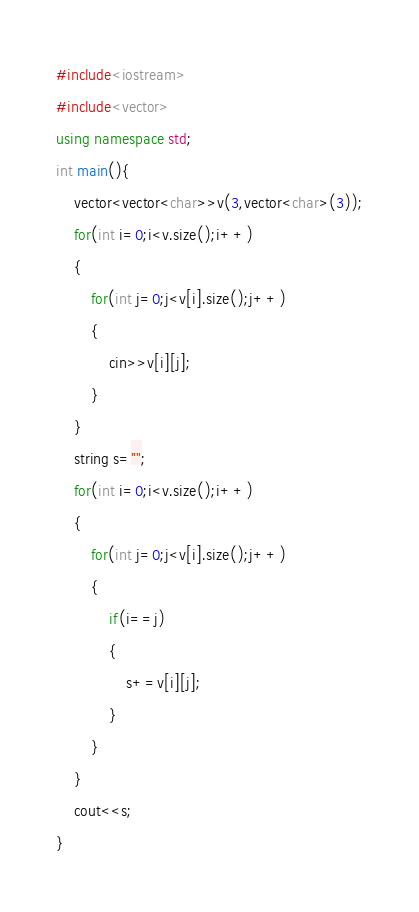<code> <loc_0><loc_0><loc_500><loc_500><_C++_>#include<iostream>
#include<vector>
using namespace std;
int main(){
    vector<vector<char>>v(3,vector<char>(3));
    for(int i=0;i<v.size();i++)
    {
        for(int j=0;j<v[i].size();j++)
        {
            cin>>v[i][j];
        }
    }
    string s="";
    for(int i=0;i<v.size();i++)
    {
        for(int j=0;j<v[i].size();j++)
        {
            if(i==j)
            {
                s+=v[i][j];
            }
        }
    }
    cout<<s;
}</code> 